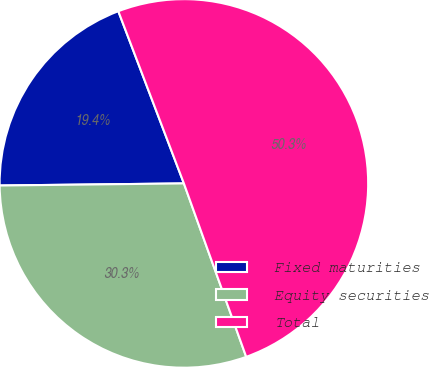<chart> <loc_0><loc_0><loc_500><loc_500><pie_chart><fcel>Fixed maturities<fcel>Equity securities<fcel>Total<nl><fcel>19.39%<fcel>30.31%<fcel>50.3%<nl></chart> 